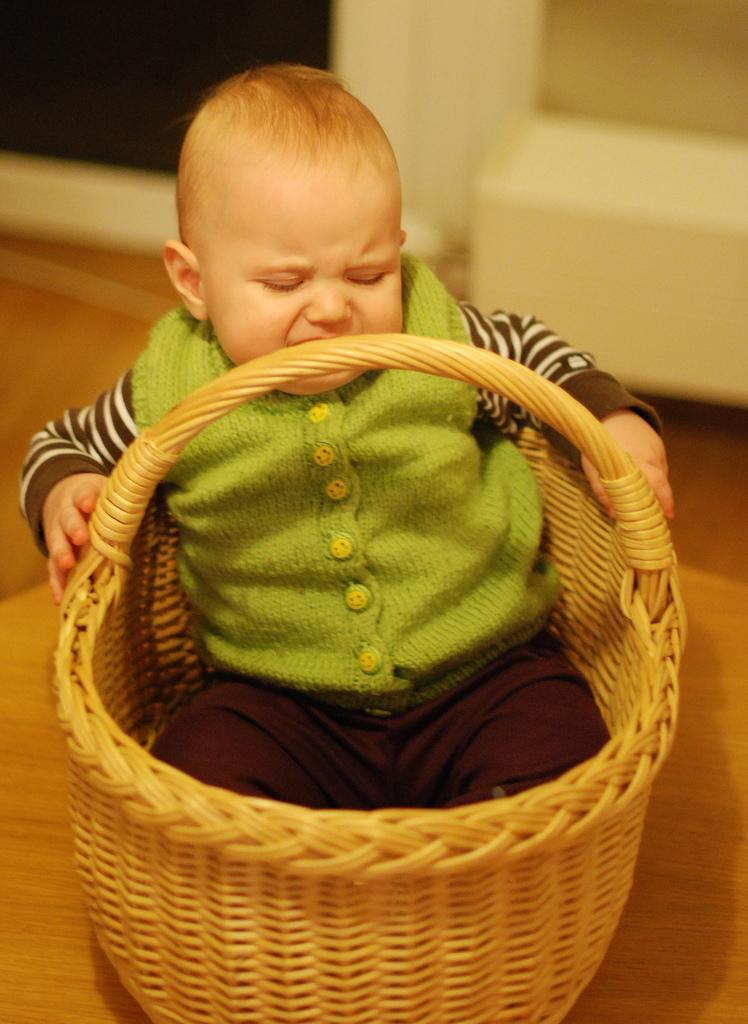Could you give a brief overview of what you see in this image? In this image we can see a boy sitting in a basket which is placed on the surface. 